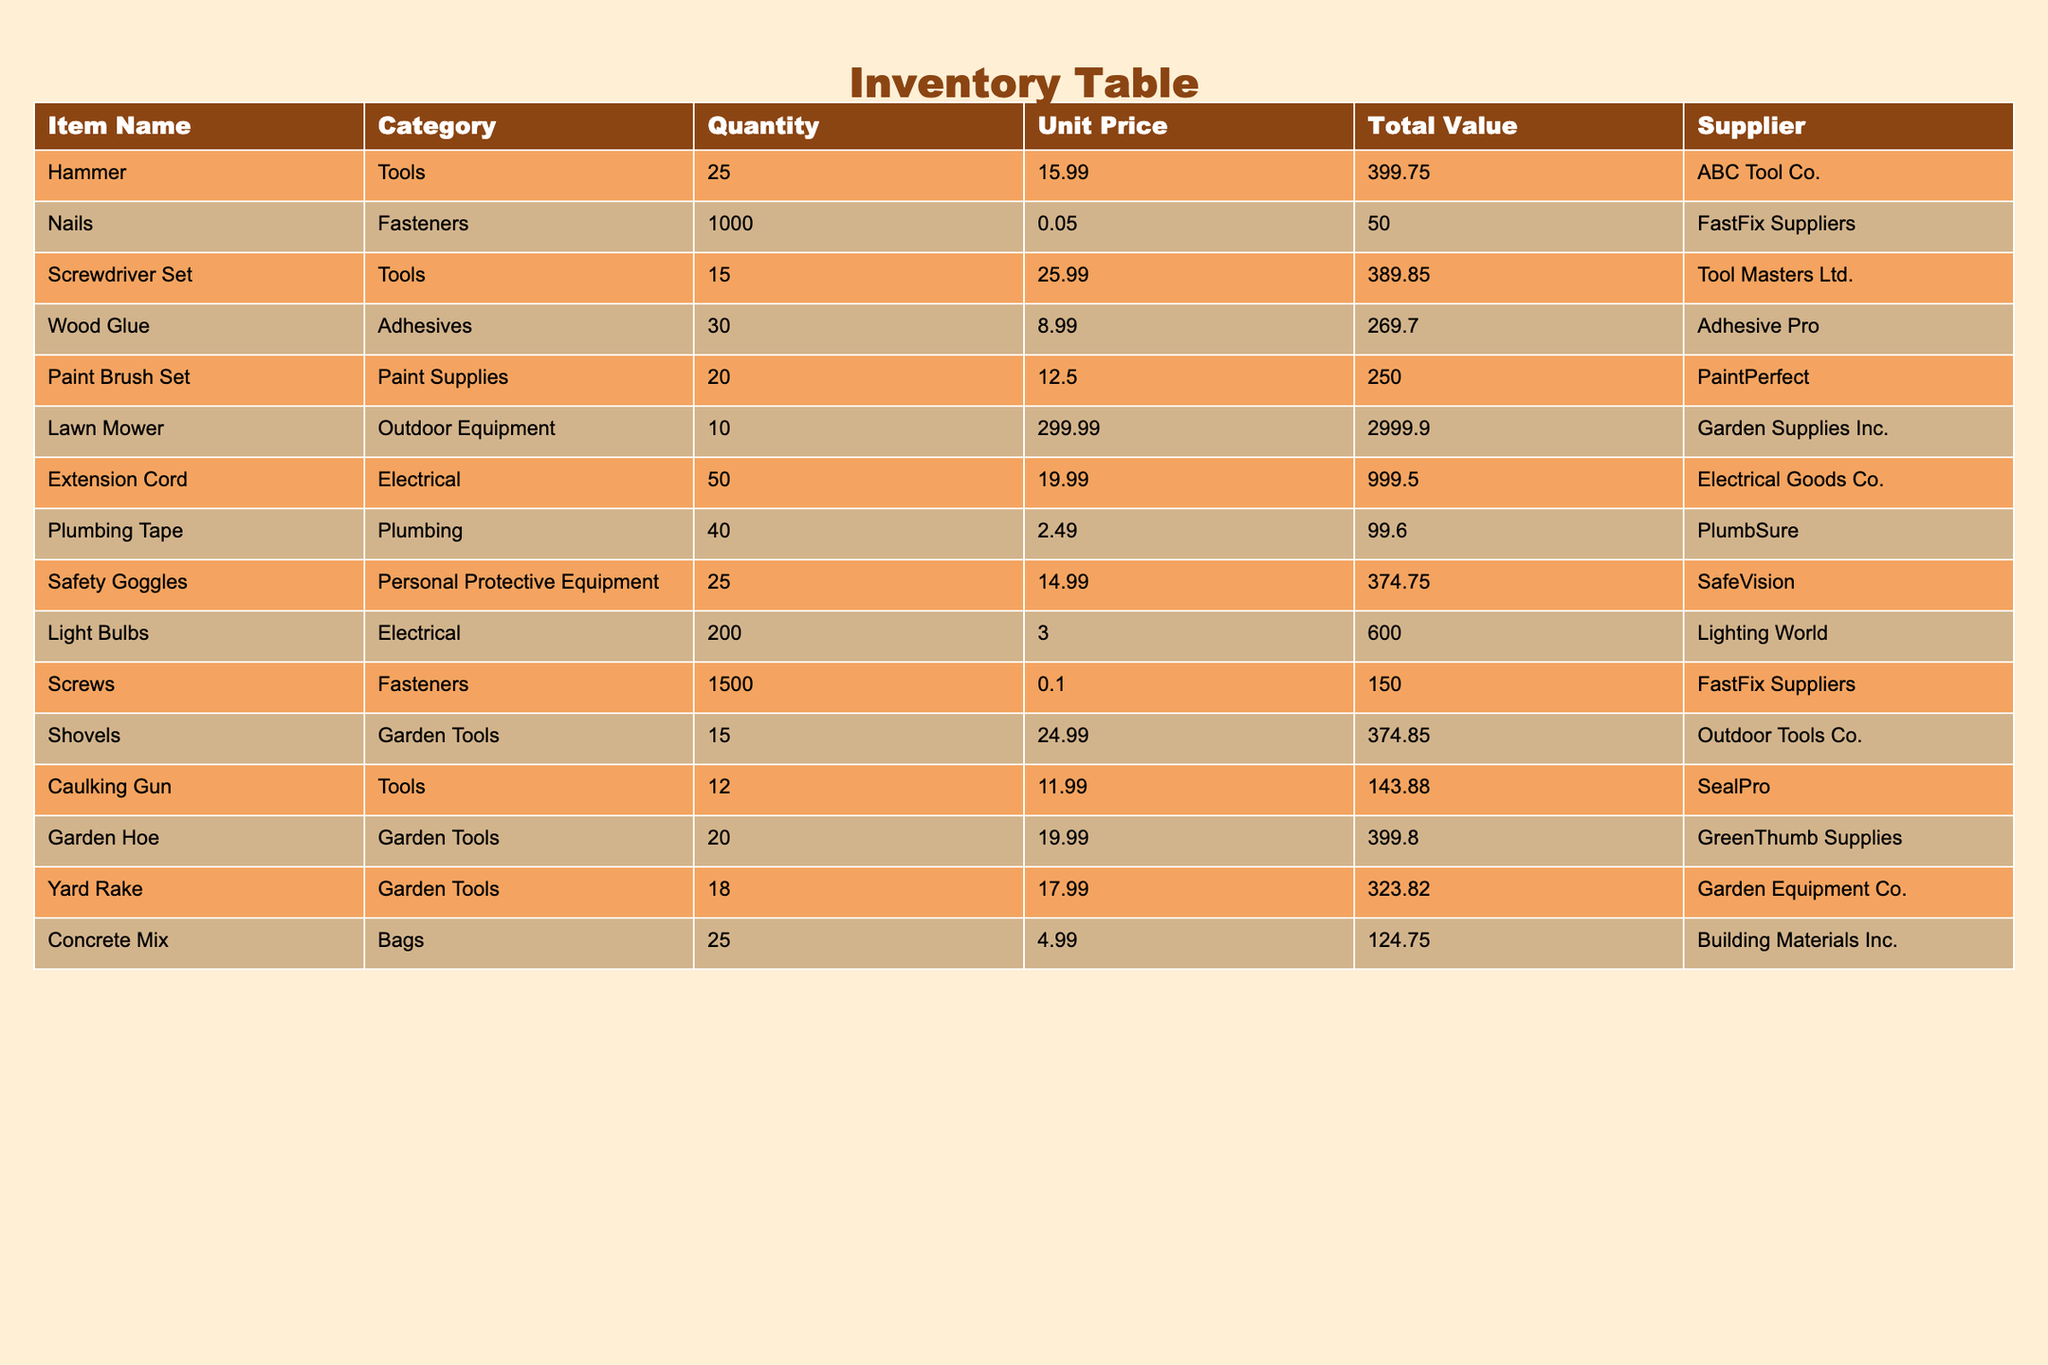What is the total quantity of screwdrivers available? According to the table, the quantity of the Screwdriver Set is listed as 15. Therefore, the total quantity of screwdrivers available is simply 15.
Answer: 15 How much is the total value of all paint supplies? The total value of the Paint Brush Set is 250.00. Since it is the only paint supply item listed, the total value of all paint supplies is also 250.00.
Answer: 250.00 Which item has the highest total value, and what is that value? From the table, the Lawn Mower has a total value of 2999.90, which is the highest among all items listed.
Answer: Lawn Mower, 2999.90 What is the average unit price of tools in the inventory? The tools listed are Hammer, Screwdriver Set, and Caulking Gun. Their unit prices are 15.99, 25.99, and 11.99 respectively. The average unit price is calculated as (15.99 + 25.99 + 11.99) / 3 = 17.99.
Answer: 17.99 Is the quantity of lawn mowers greater than that of safety goggles? The quantity of Lawn Mowers is 10, and the quantity of Safety Goggles is 25. Since 10 is less than 25, the statement is false.
Answer: No What is the total value of all items in the Electrical category? The items in the Electrical category are Extension Cord and Light Bulbs. Their total values are 999.50 and 600.00 respectively. Summing these gives 999.50 + 600.00 = 1599.50 as the total value of Electrical items.
Answer: 1599.50 Which supplier provides the most items in the inventory, and how many do they provide? The suppliers for Fasteners are FastFix Suppliers (with Nails and Screws), providing a total of 2500 items (1000 + 1500). Comparing with others, FastFix Suppliers provides the most items.
Answer: FastFix Suppliers, 2500 What is the difference in total value between the highest and lowest valued items in the inventory? The highest total value is that of the Lawn Mower at 2999.90, and the lowest total value is that of Plumbing Tape at 99.60. The difference is calculated as 2999.90 - 99.60 = 2900.30.
Answer: 2900.30 Are there more fasteners or garden tools in the inventory? Fasteners total 2500 (1000 Nails + 1500 Screws) while the total quantity for garden tools (Shovels, Garden Hoe, Yard Rake) is 53 (15 + 20 + 18). Since 2500 is greater than 53, the answer is yes.
Answer: Yes 